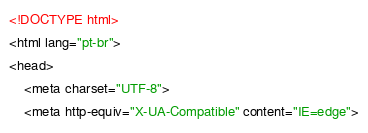Convert code to text. <code><loc_0><loc_0><loc_500><loc_500><_HTML_><!DOCTYPE html>
<html lang="pt-br">
<head>
    <meta charset="UTF-8">
    <meta http-equiv="X-UA-Compatible" content="IE=edge"></code> 